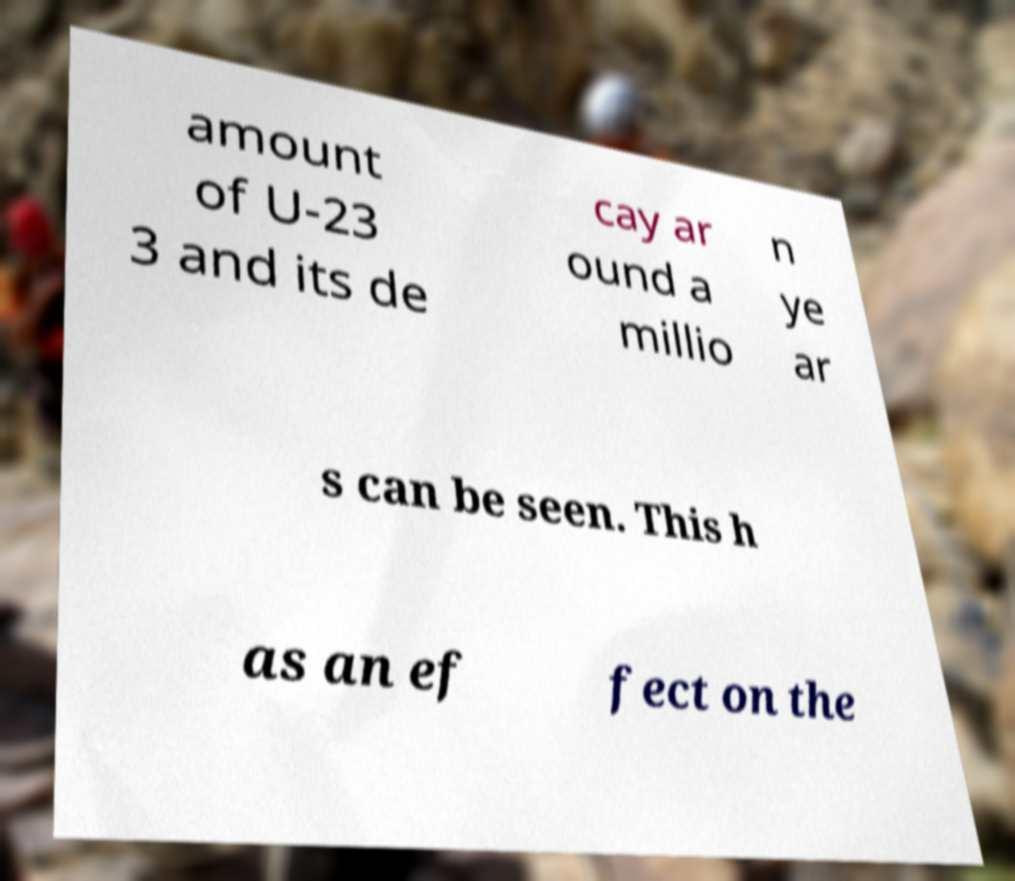Could you assist in decoding the text presented in this image and type it out clearly? amount of U-23 3 and its de cay ar ound a millio n ye ar s can be seen. This h as an ef fect on the 